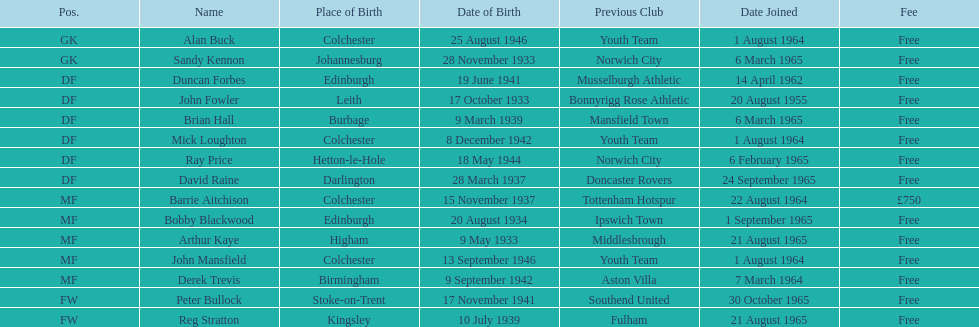Is arthur kaye older or younger than brian hill? Older. 